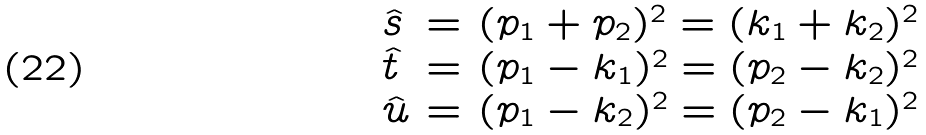<formula> <loc_0><loc_0><loc_500><loc_500>\begin{array} { l l l } \hat { s } & = & ( p _ { 1 } + p _ { 2 } ) ^ { 2 } = ( k _ { 1 } + k _ { 2 } ) ^ { 2 } \\ \hat { t } & = & ( p _ { 1 } - k _ { 1 } ) ^ { 2 } = ( p _ { 2 } - k _ { 2 } ) ^ { 2 } \\ \hat { u } & = & ( p _ { 1 } - k _ { 2 } ) ^ { 2 } = ( p _ { 2 } - k _ { 1 } ) ^ { 2 } \end{array}</formula> 